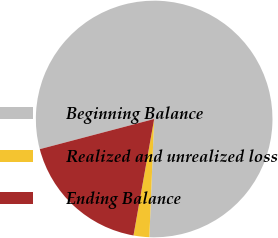Convert chart. <chart><loc_0><loc_0><loc_500><loc_500><pie_chart><fcel>Beginning Balance<fcel>Realized and unrealized loss<fcel>Ending Balance<nl><fcel>79.75%<fcel>2.15%<fcel>18.1%<nl></chart> 